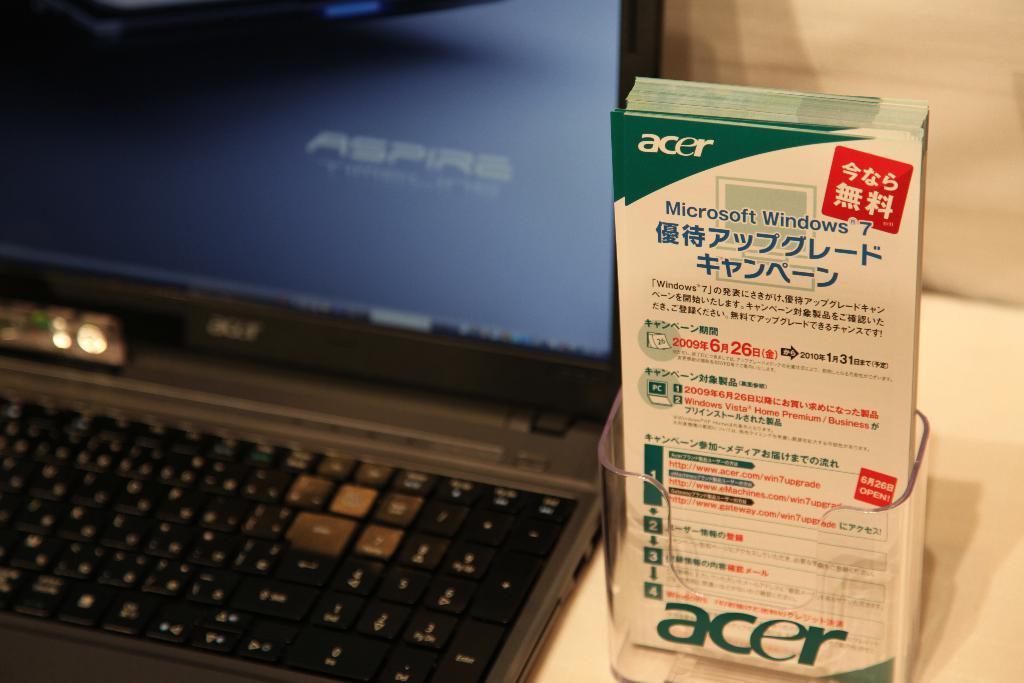What brand is this laptop?
Your answer should be very brief. Acer. 